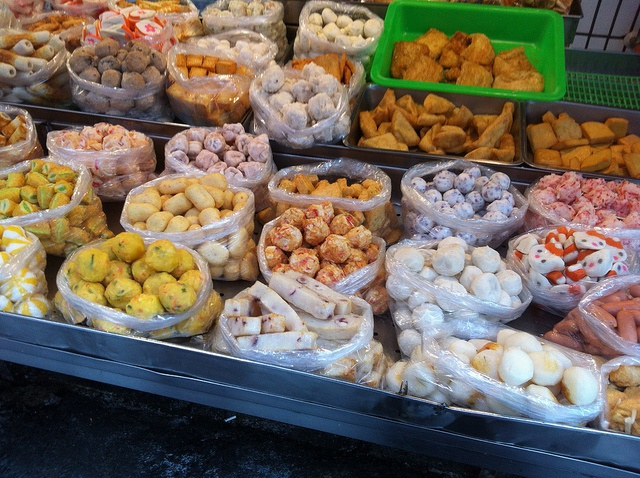Describe the objects in this image and their specific colors. I can see bowl in tan, green, darkgreen, olive, and maroon tones and donut in tan, maroon, and brown tones in this image. 